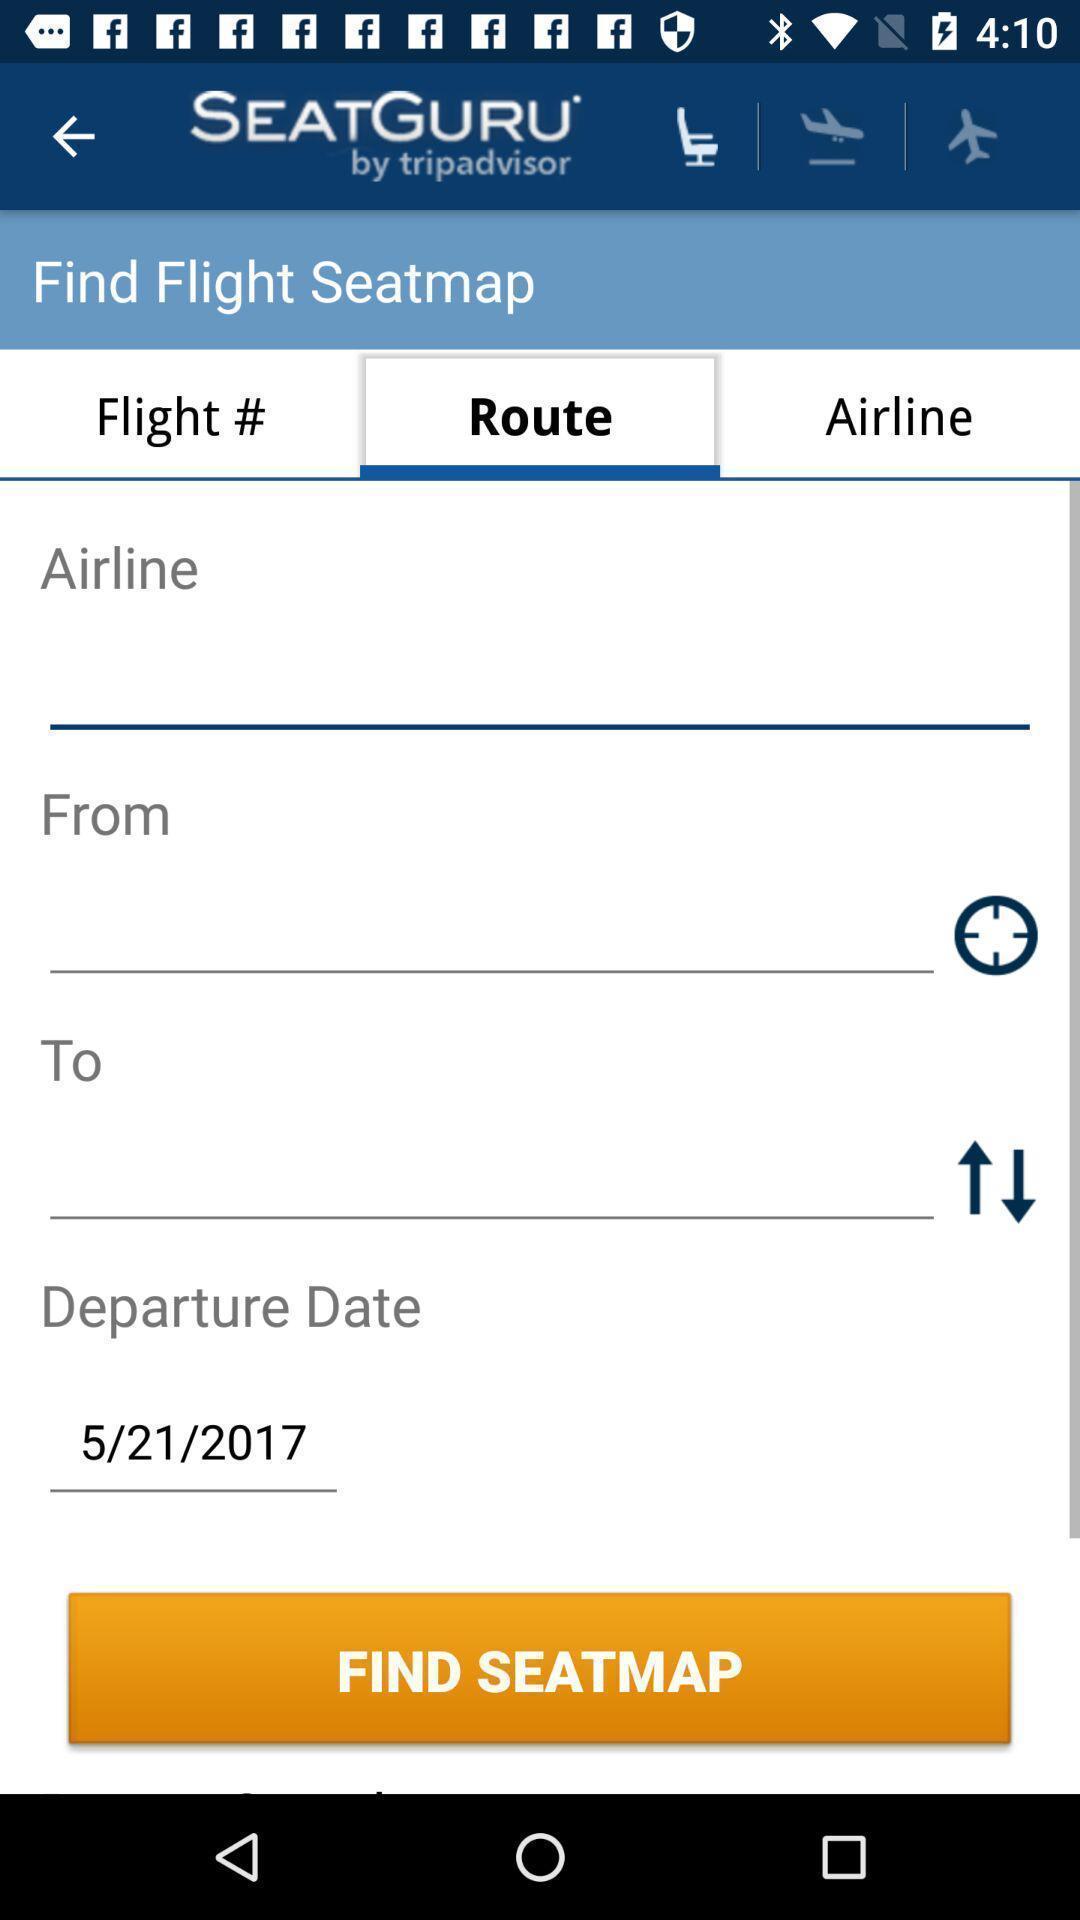What details can you identify in this image? Seatguru flight booking app shows travel information filling tabs. 